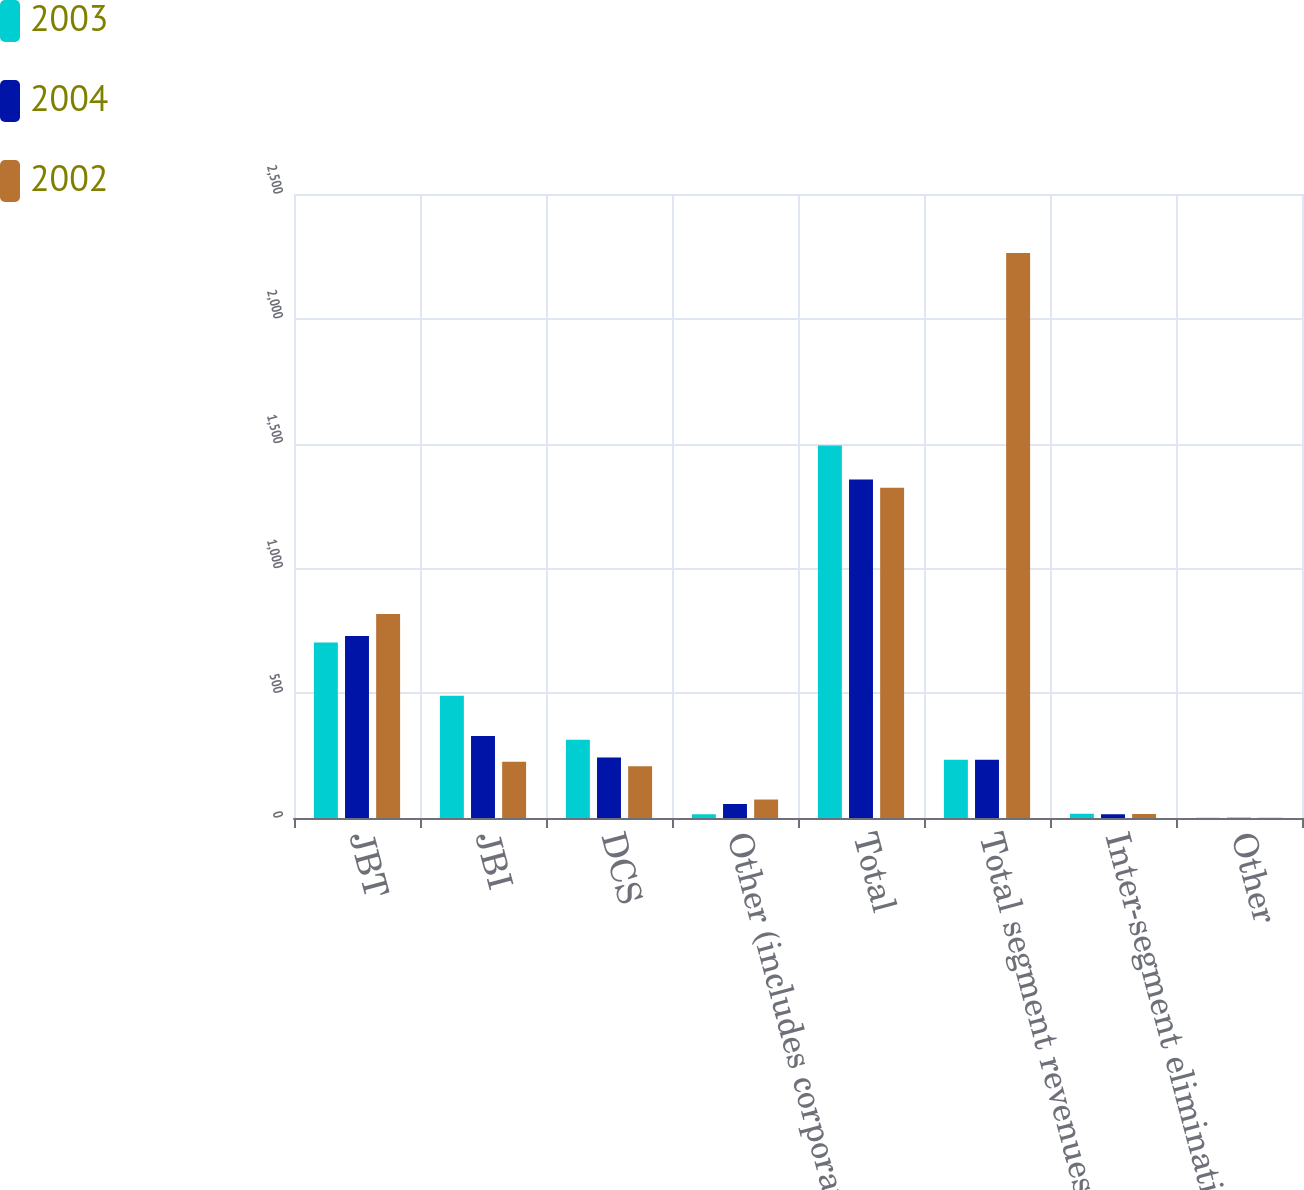Convert chart. <chart><loc_0><loc_0><loc_500><loc_500><stacked_bar_chart><ecel><fcel>JBT<fcel>JBI<fcel>DCS<fcel>Other (includes corporate)<fcel>Total<fcel>Total segment revenues<fcel>Inter-segment eliminations<fcel>Other<nl><fcel>2003<fcel>703<fcel>490<fcel>314<fcel>15<fcel>1492<fcel>233.5<fcel>17<fcel>1<nl><fcel>2004<fcel>729<fcel>329<fcel>242<fcel>56<fcel>1356<fcel>233.5<fcel>15<fcel>1<nl><fcel>2002<fcel>817<fcel>225<fcel>207<fcel>74<fcel>1323<fcel>2264<fcel>16<fcel>1<nl></chart> 